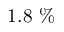<formula> <loc_0><loc_0><loc_500><loc_500>1 . 8 \ \%</formula> 